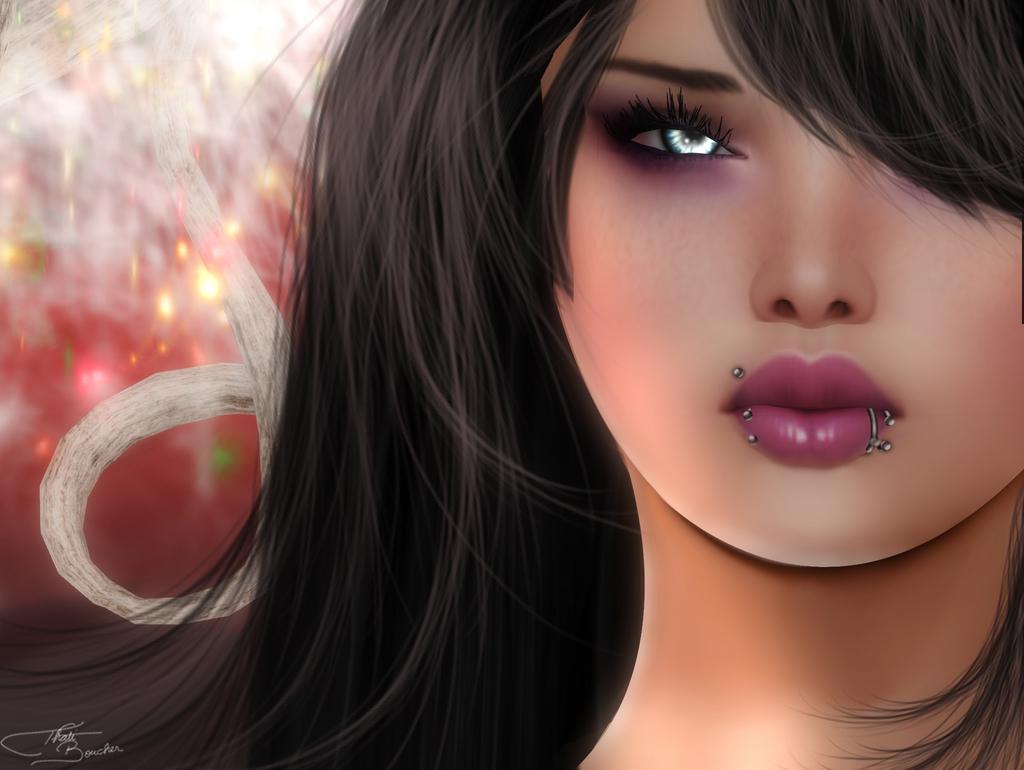Can you describe this image briefly? In this image there is a digital art of a girl. 